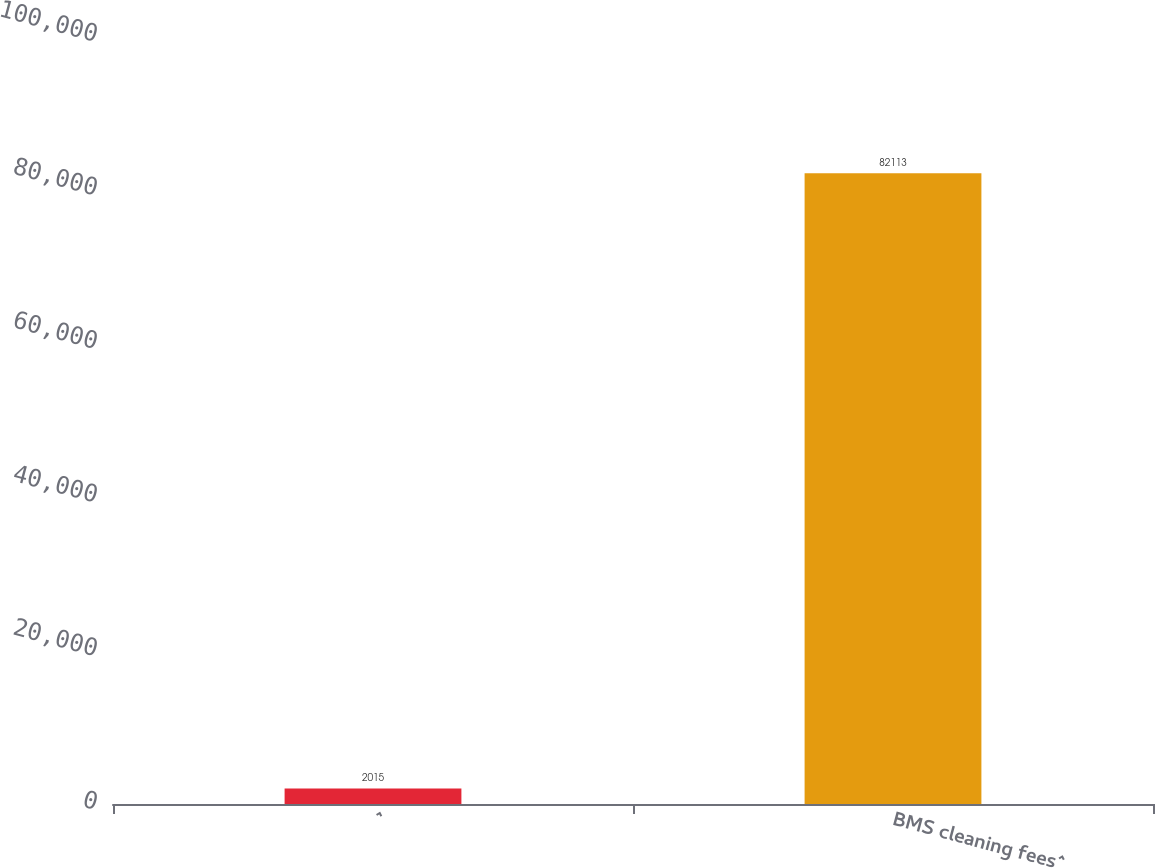Convert chart. <chart><loc_0><loc_0><loc_500><loc_500><bar_chart><fcel>^<fcel>BMS cleaning fees^<nl><fcel>2015<fcel>82113<nl></chart> 